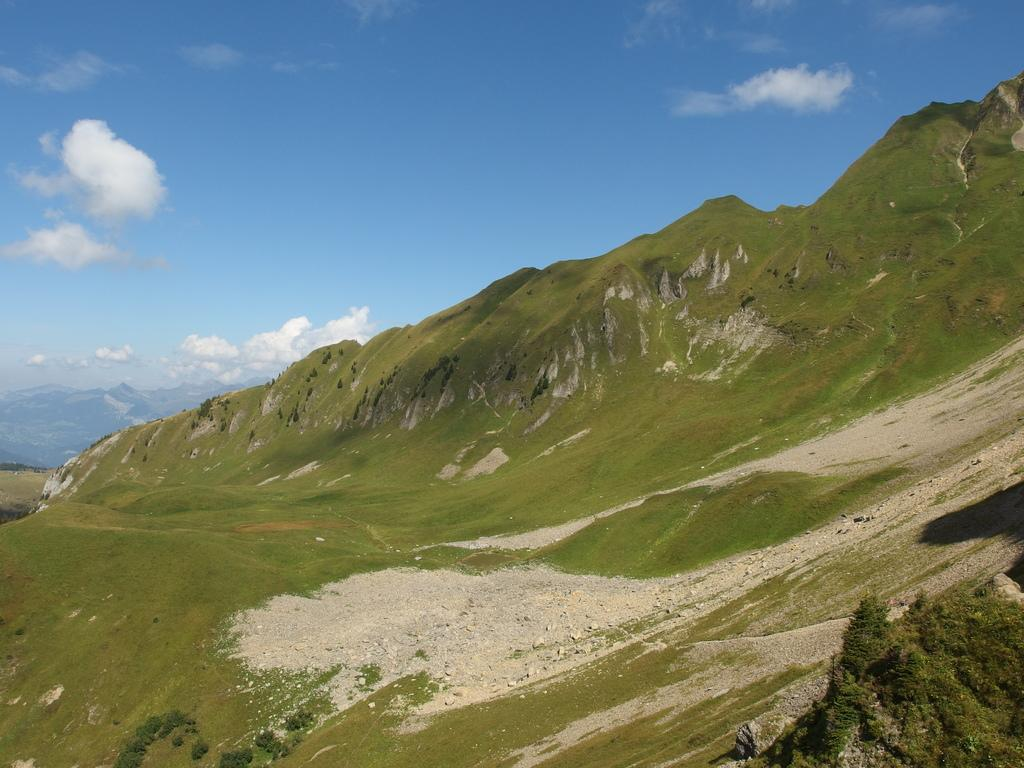What type of natural features can be seen in the image? There are hills and mountains in the image. Where are the mountains located in the image? The mountains are visible in the background of the image. What type of vegetation is present at the bottom of the image? There are plants at the bottom of the image. What is visible at the top of the image? The sky is visible at the top of the image. How many chairs can be seen in the image? There are no chairs present in the image. What type of support is provided by the eggnog in the image? There is no eggnog present in the image, so it cannot provide any support. 